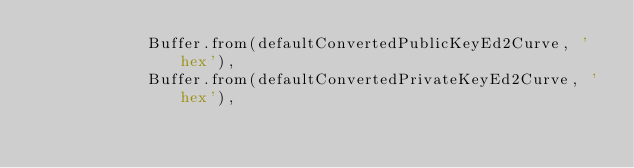Convert code to text. <code><loc_0><loc_0><loc_500><loc_500><_JavaScript_>			Buffer.from(defaultConvertedPublicKeyEd2Curve, 'hex'),
			Buffer.from(defaultConvertedPrivateKeyEd2Curve, 'hex'),</code> 